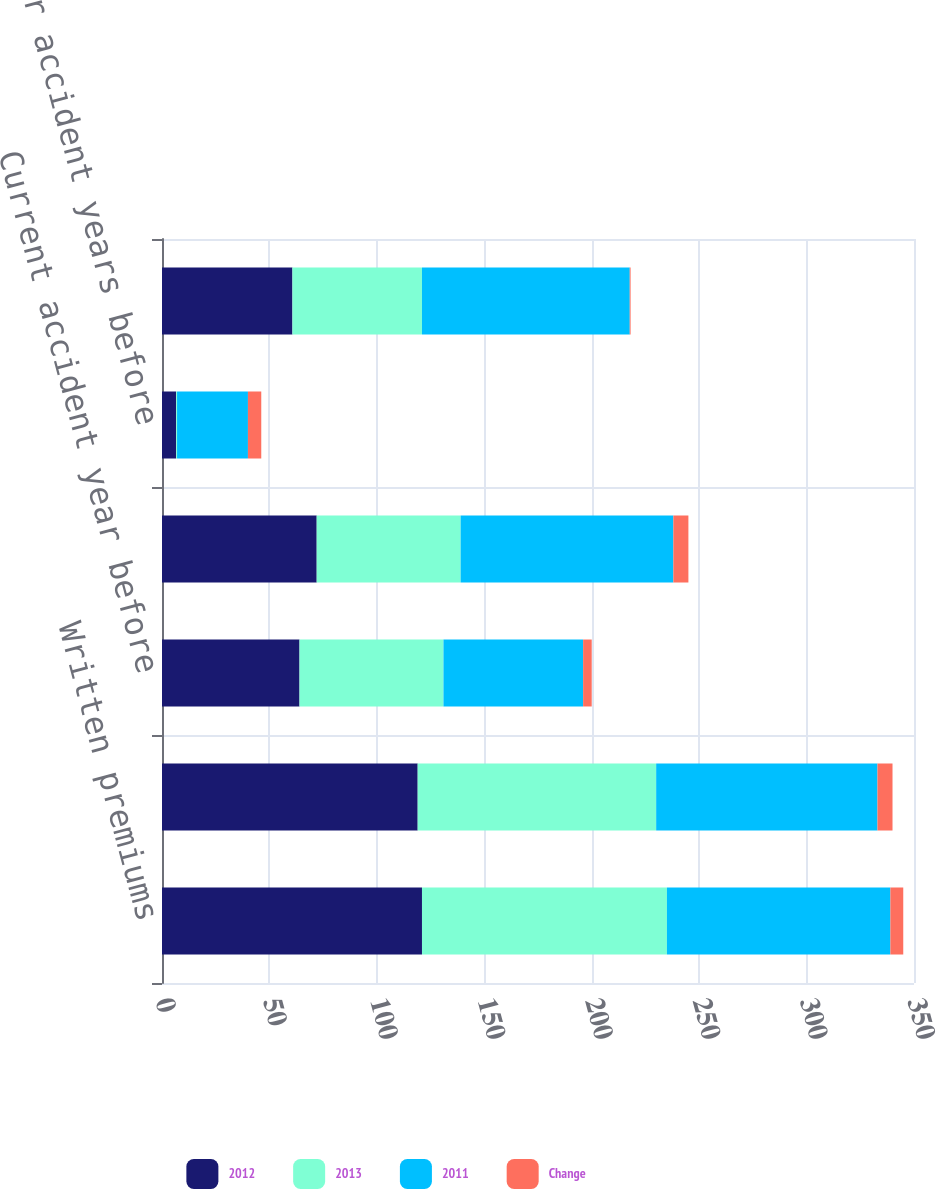Convert chart to OTSL. <chart><loc_0><loc_0><loc_500><loc_500><stacked_bar_chart><ecel><fcel>Written premiums<fcel>Earned premiums<fcel>Current accident year before<fcel>Total loss and loss expenses<fcel>Prior accident years before<fcel>Total loss and loss expense<nl><fcel>2012<fcel>121<fcel>119<fcel>64<fcel>72<fcel>6.6<fcel>60.7<nl><fcel>2013<fcel>114<fcel>111<fcel>67<fcel>67<fcel>0.4<fcel>60.3<nl><fcel>2011<fcel>104<fcel>103<fcel>65<fcel>99<fcel>33<fcel>96.7<nl><fcel>Change<fcel>6<fcel>7<fcel>4<fcel>7<fcel>6.2<fcel>0.4<nl></chart> 